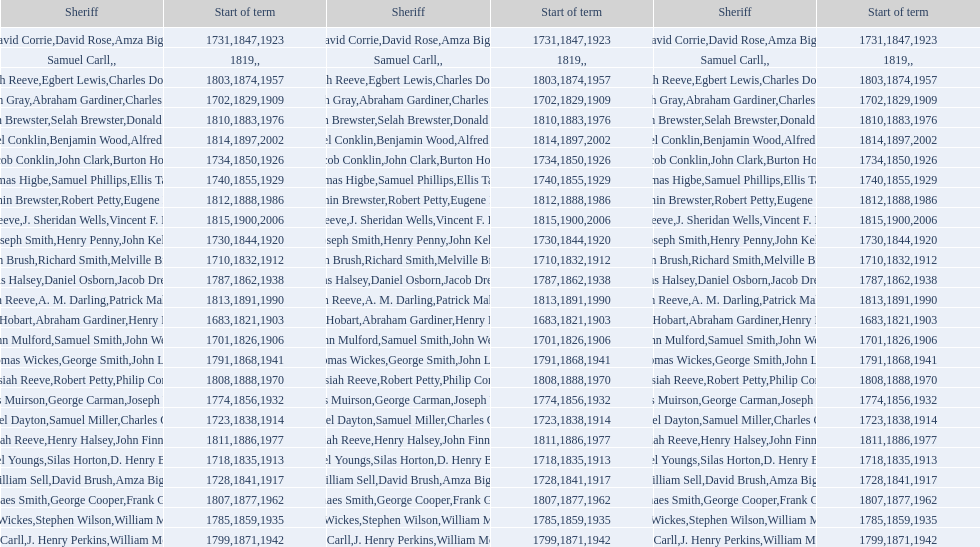Did robert petty serve before josiah reeve? No. 